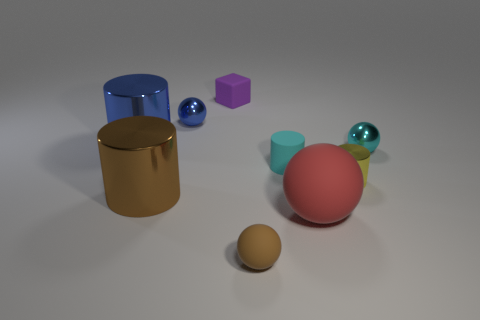Add 1 yellow objects. How many objects exist? 10 Subtract all balls. How many objects are left? 5 Add 7 small purple blocks. How many small purple blocks are left? 8 Add 7 large things. How many large things exist? 10 Subtract 0 green cylinders. How many objects are left? 9 Subtract all rubber cylinders. Subtract all tiny cyan spheres. How many objects are left? 7 